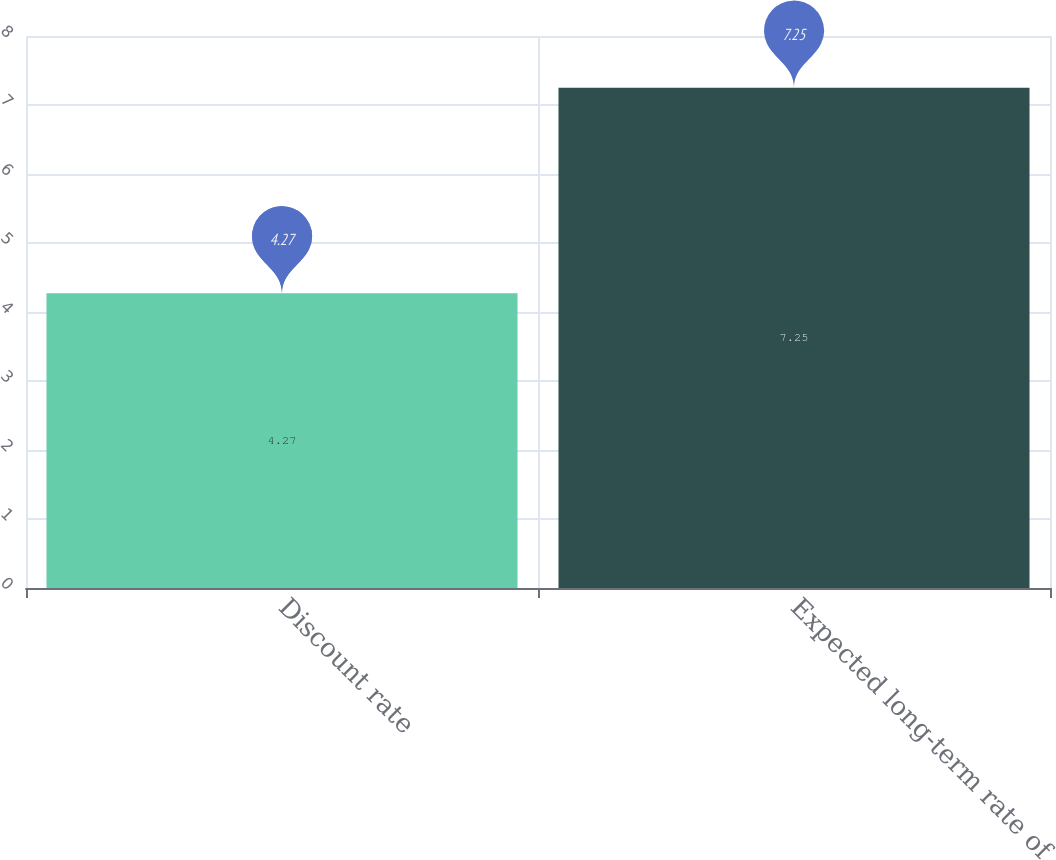Convert chart. <chart><loc_0><loc_0><loc_500><loc_500><bar_chart><fcel>Discount rate<fcel>Expected long-term rate of<nl><fcel>4.27<fcel>7.25<nl></chart> 